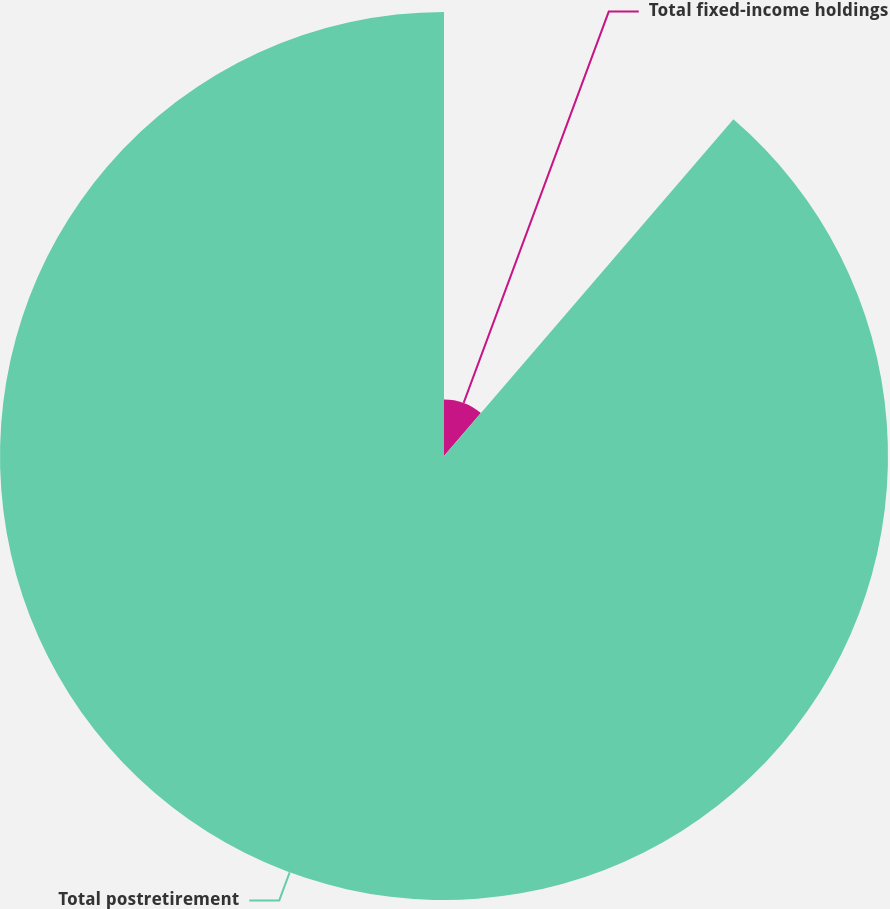Convert chart to OTSL. <chart><loc_0><loc_0><loc_500><loc_500><pie_chart><fcel>Total fixed-income holdings<fcel>Total postretirement<nl><fcel>11.3%<fcel>88.7%<nl></chart> 